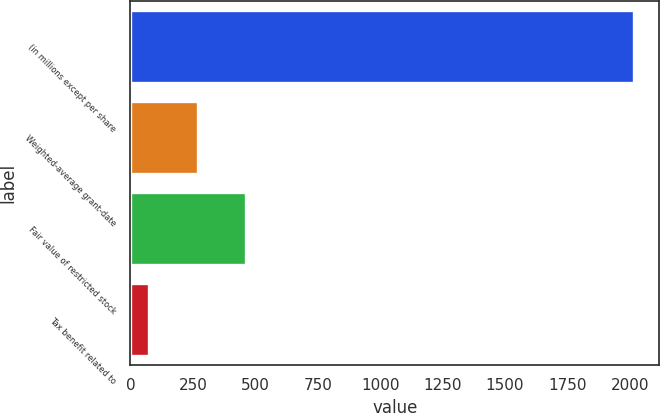Convert chart. <chart><loc_0><loc_0><loc_500><loc_500><bar_chart><fcel>(in millions except per share<fcel>Weighted-average grant-date<fcel>Fair value of restricted stock<fcel>Tax benefit related to<nl><fcel>2016<fcel>270<fcel>464<fcel>76<nl></chart> 